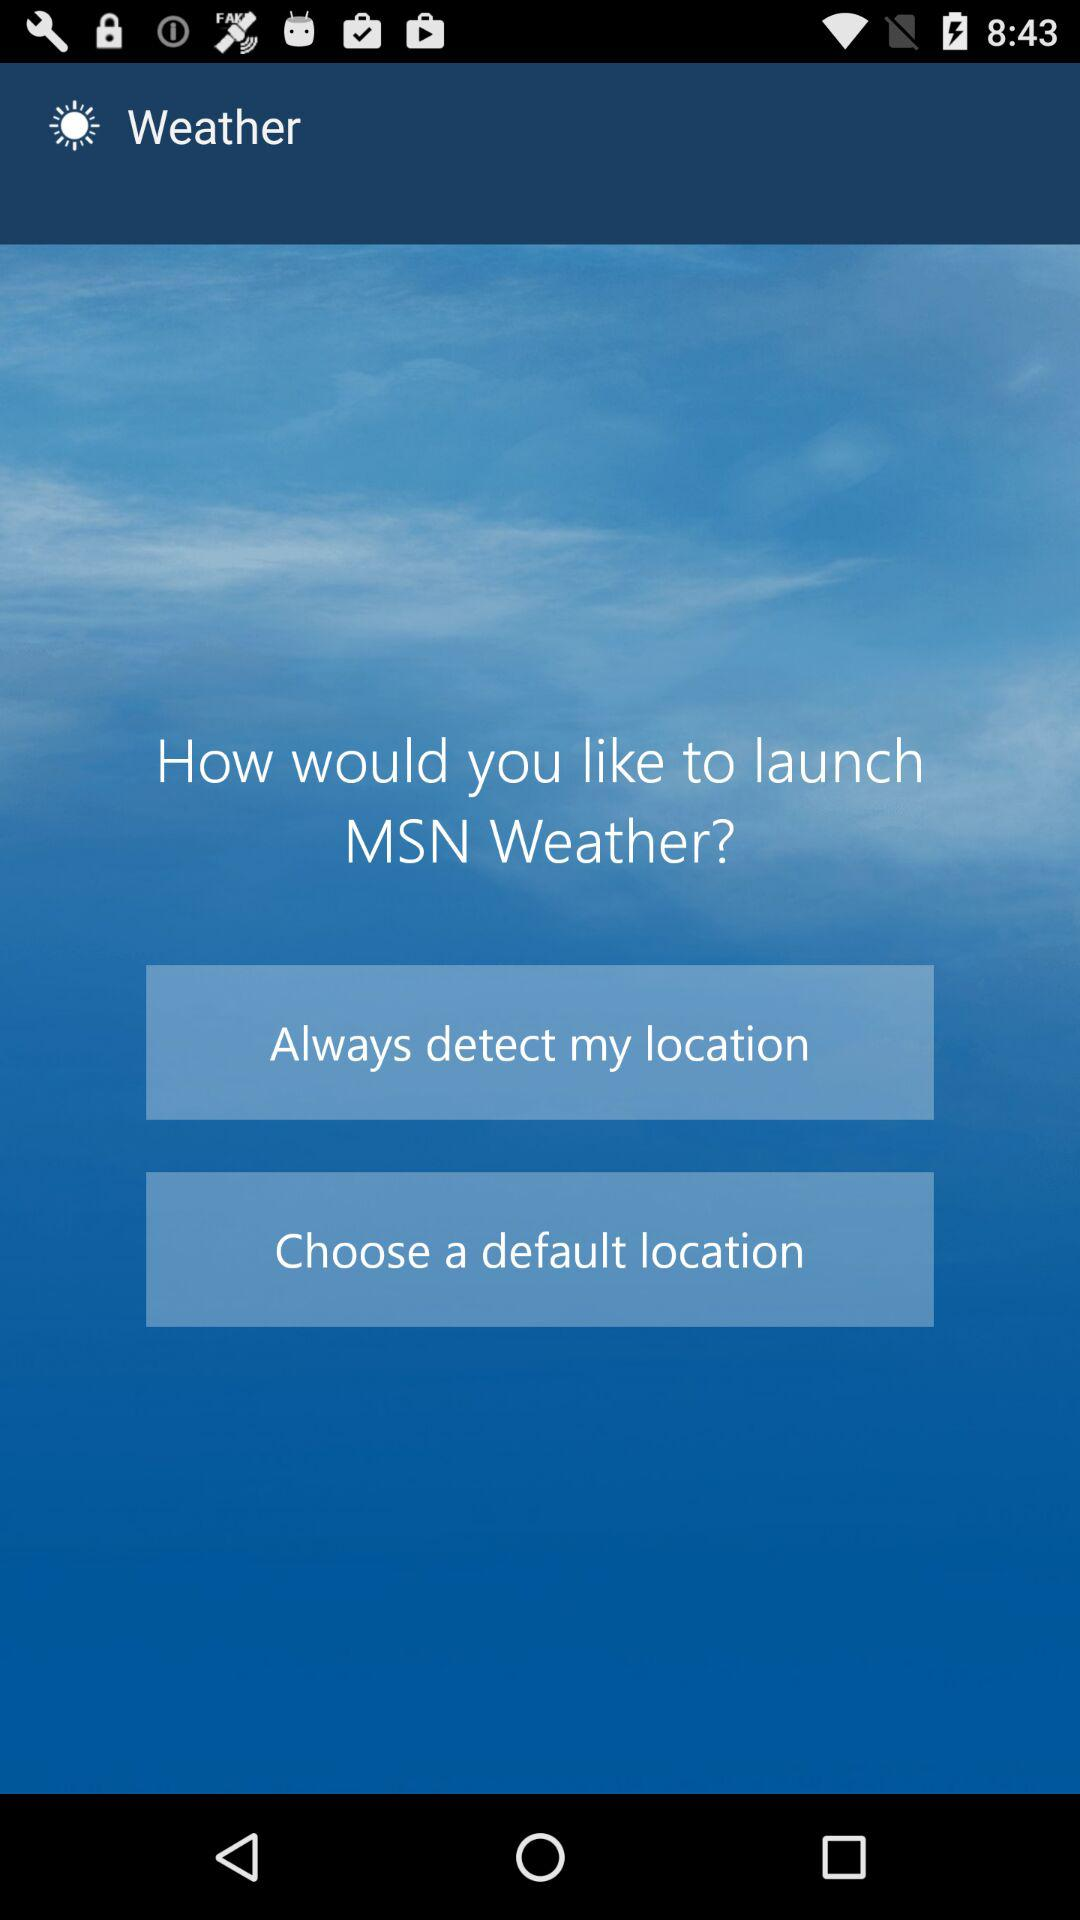What is the app name? The app name is "Weather". 